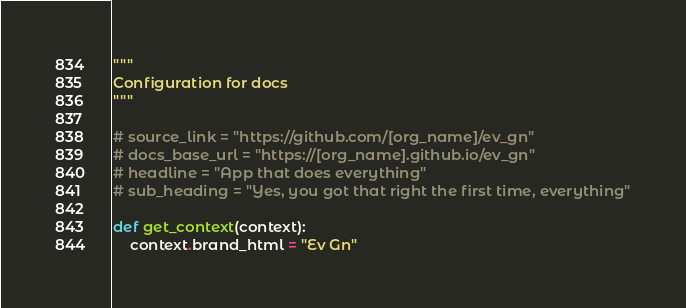<code> <loc_0><loc_0><loc_500><loc_500><_Python_>"""
Configuration for docs
"""

# source_link = "https://github.com/[org_name]/ev_gn"
# docs_base_url = "https://[org_name].github.io/ev_gn"
# headline = "App that does everything"
# sub_heading = "Yes, you got that right the first time, everything"

def get_context(context):
	context.brand_html = "Ev Gn"
</code> 